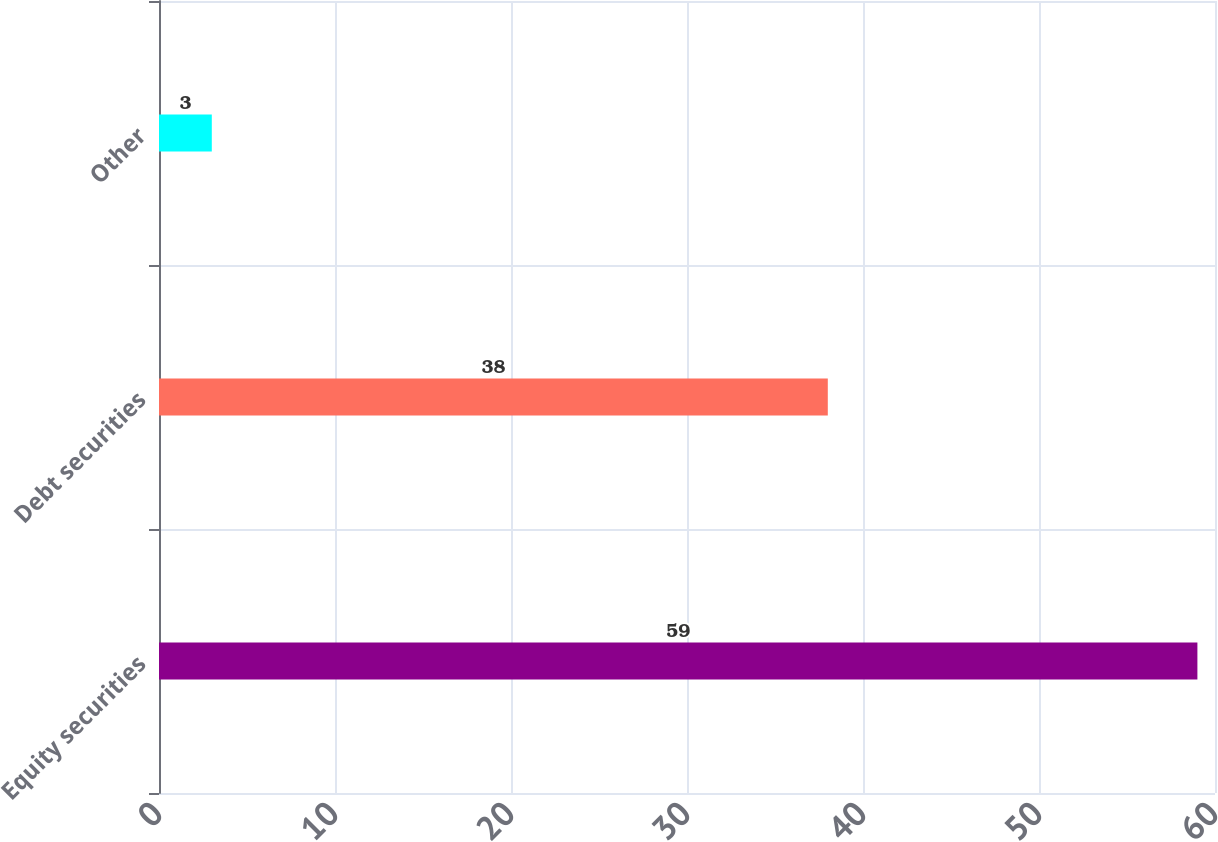<chart> <loc_0><loc_0><loc_500><loc_500><bar_chart><fcel>Equity securities<fcel>Debt securities<fcel>Other<nl><fcel>59<fcel>38<fcel>3<nl></chart> 